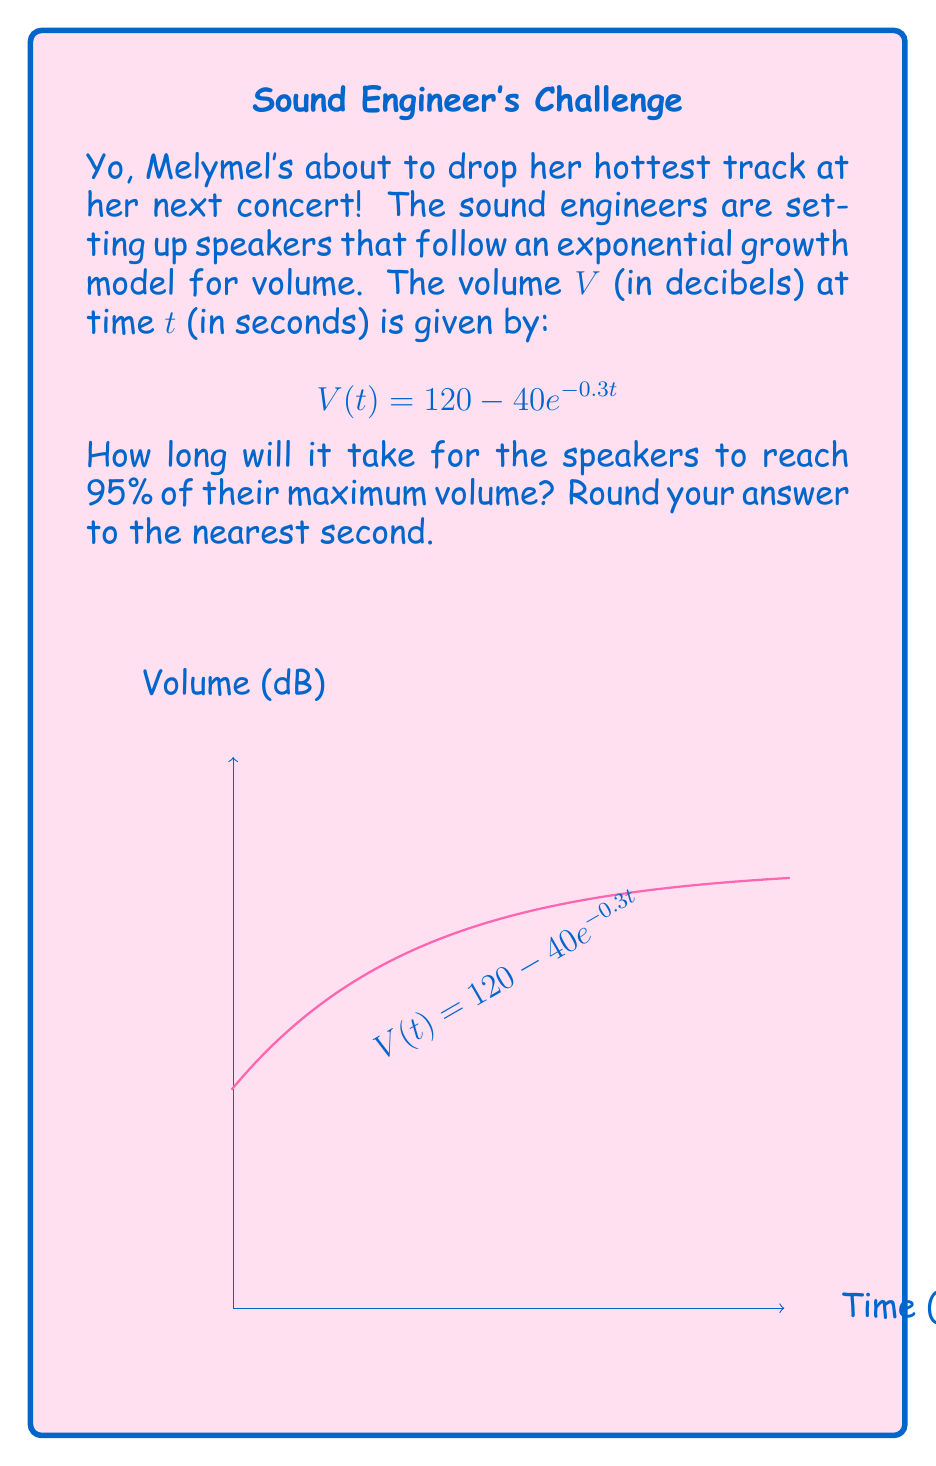Can you solve this math problem? Let's approach this step-by-step:

1) First, we need to determine the maximum volume. As $t$ approaches infinity, $e^{-0.3t}$ approaches 0, so:

   $\lim_{t \to \infty} V(t) = 120 - 40 \cdot 0 = 120$ dB

2) We want to find when the volume reaches 95% of this maximum:

   $0.95 \cdot 120 = 114$ dB

3) Now, we can set up our equation:

   $114 = 120 - 40e^{-0.3t}$

4) Subtract 120 from both sides:

   $-6 = -40e^{-0.3t}$

5) Divide both sides by -40:

   $0.15 = e^{-0.3t}$

6) Take the natural log of both sides:

   $\ln(0.15) = -0.3t$

7) Divide both sides by -0.3:

   $\frac{\ln(0.15)}{-0.3} = t$

8) Calculate:

   $t \approx 6.32$ seconds

9) Rounding to the nearest second:

   $t = 6$ seconds
Answer: 6 seconds 